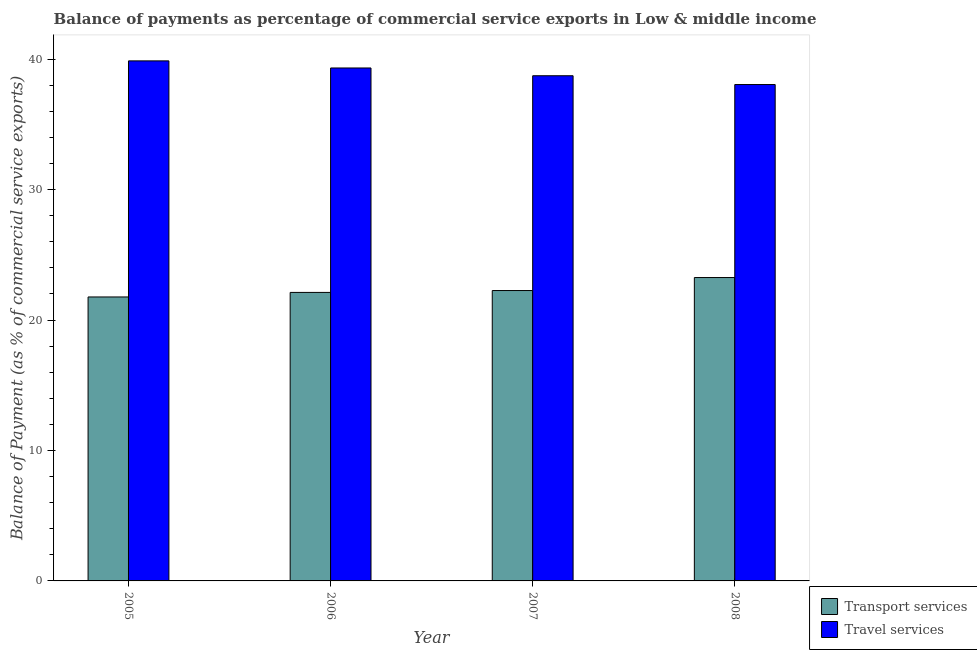How many different coloured bars are there?
Your answer should be compact. 2. How many groups of bars are there?
Give a very brief answer. 4. Are the number of bars per tick equal to the number of legend labels?
Provide a short and direct response. Yes. How many bars are there on the 1st tick from the right?
Ensure brevity in your answer.  2. What is the balance of payments of transport services in 2006?
Your response must be concise. 22.12. Across all years, what is the maximum balance of payments of transport services?
Keep it short and to the point. 23.26. Across all years, what is the minimum balance of payments of travel services?
Make the answer very short. 38.06. In which year was the balance of payments of travel services minimum?
Offer a terse response. 2008. What is the total balance of payments of travel services in the graph?
Your response must be concise. 155.98. What is the difference between the balance of payments of travel services in 2006 and that in 2008?
Ensure brevity in your answer.  1.27. What is the difference between the balance of payments of transport services in 2008 and the balance of payments of travel services in 2007?
Your response must be concise. 1. What is the average balance of payments of transport services per year?
Give a very brief answer. 22.35. What is the ratio of the balance of payments of transport services in 2006 to that in 2007?
Make the answer very short. 0.99. Is the balance of payments of travel services in 2006 less than that in 2007?
Ensure brevity in your answer.  No. Is the difference between the balance of payments of transport services in 2005 and 2007 greater than the difference between the balance of payments of travel services in 2005 and 2007?
Provide a succinct answer. No. What is the difference between the highest and the second highest balance of payments of transport services?
Make the answer very short. 1. What is the difference between the highest and the lowest balance of payments of travel services?
Provide a succinct answer. 1.81. In how many years, is the balance of payments of transport services greater than the average balance of payments of transport services taken over all years?
Provide a succinct answer. 1. Is the sum of the balance of payments of travel services in 2007 and 2008 greater than the maximum balance of payments of transport services across all years?
Keep it short and to the point. Yes. What does the 1st bar from the left in 2006 represents?
Provide a short and direct response. Transport services. What does the 2nd bar from the right in 2006 represents?
Ensure brevity in your answer.  Transport services. How many bars are there?
Ensure brevity in your answer.  8. Are all the bars in the graph horizontal?
Keep it short and to the point. No. How many years are there in the graph?
Make the answer very short. 4. Are the values on the major ticks of Y-axis written in scientific E-notation?
Offer a very short reply. No. Does the graph contain any zero values?
Your response must be concise. No. How are the legend labels stacked?
Your answer should be very brief. Vertical. What is the title of the graph?
Offer a terse response. Balance of payments as percentage of commercial service exports in Low & middle income. Does "Current education expenditure" appear as one of the legend labels in the graph?
Keep it short and to the point. No. What is the label or title of the X-axis?
Your answer should be very brief. Year. What is the label or title of the Y-axis?
Provide a succinct answer. Balance of Payment (as % of commercial service exports). What is the Balance of Payment (as % of commercial service exports) of Transport services in 2005?
Your response must be concise. 21.77. What is the Balance of Payment (as % of commercial service exports) of Travel services in 2005?
Offer a very short reply. 39.87. What is the Balance of Payment (as % of commercial service exports) in Transport services in 2006?
Provide a short and direct response. 22.12. What is the Balance of Payment (as % of commercial service exports) in Travel services in 2006?
Your answer should be compact. 39.33. What is the Balance of Payment (as % of commercial service exports) of Transport services in 2007?
Provide a succinct answer. 22.26. What is the Balance of Payment (as % of commercial service exports) in Travel services in 2007?
Provide a succinct answer. 38.73. What is the Balance of Payment (as % of commercial service exports) of Transport services in 2008?
Offer a very short reply. 23.26. What is the Balance of Payment (as % of commercial service exports) of Travel services in 2008?
Give a very brief answer. 38.06. Across all years, what is the maximum Balance of Payment (as % of commercial service exports) in Transport services?
Provide a short and direct response. 23.26. Across all years, what is the maximum Balance of Payment (as % of commercial service exports) in Travel services?
Provide a succinct answer. 39.87. Across all years, what is the minimum Balance of Payment (as % of commercial service exports) of Transport services?
Give a very brief answer. 21.77. Across all years, what is the minimum Balance of Payment (as % of commercial service exports) of Travel services?
Provide a succinct answer. 38.06. What is the total Balance of Payment (as % of commercial service exports) of Transport services in the graph?
Provide a succinct answer. 89.41. What is the total Balance of Payment (as % of commercial service exports) in Travel services in the graph?
Ensure brevity in your answer.  155.98. What is the difference between the Balance of Payment (as % of commercial service exports) in Transport services in 2005 and that in 2006?
Offer a terse response. -0.35. What is the difference between the Balance of Payment (as % of commercial service exports) in Travel services in 2005 and that in 2006?
Offer a very short reply. 0.54. What is the difference between the Balance of Payment (as % of commercial service exports) of Transport services in 2005 and that in 2007?
Provide a short and direct response. -0.49. What is the difference between the Balance of Payment (as % of commercial service exports) of Travel services in 2005 and that in 2007?
Give a very brief answer. 1.14. What is the difference between the Balance of Payment (as % of commercial service exports) in Transport services in 2005 and that in 2008?
Make the answer very short. -1.49. What is the difference between the Balance of Payment (as % of commercial service exports) of Travel services in 2005 and that in 2008?
Keep it short and to the point. 1.81. What is the difference between the Balance of Payment (as % of commercial service exports) of Transport services in 2006 and that in 2007?
Your response must be concise. -0.14. What is the difference between the Balance of Payment (as % of commercial service exports) in Travel services in 2006 and that in 2007?
Give a very brief answer. 0.6. What is the difference between the Balance of Payment (as % of commercial service exports) of Transport services in 2006 and that in 2008?
Offer a terse response. -1.14. What is the difference between the Balance of Payment (as % of commercial service exports) in Travel services in 2006 and that in 2008?
Provide a short and direct response. 1.27. What is the difference between the Balance of Payment (as % of commercial service exports) in Transport services in 2007 and that in 2008?
Your answer should be compact. -1. What is the difference between the Balance of Payment (as % of commercial service exports) of Travel services in 2007 and that in 2008?
Provide a short and direct response. 0.67. What is the difference between the Balance of Payment (as % of commercial service exports) of Transport services in 2005 and the Balance of Payment (as % of commercial service exports) of Travel services in 2006?
Provide a short and direct response. -17.56. What is the difference between the Balance of Payment (as % of commercial service exports) in Transport services in 2005 and the Balance of Payment (as % of commercial service exports) in Travel services in 2007?
Your answer should be compact. -16.96. What is the difference between the Balance of Payment (as % of commercial service exports) of Transport services in 2005 and the Balance of Payment (as % of commercial service exports) of Travel services in 2008?
Ensure brevity in your answer.  -16.28. What is the difference between the Balance of Payment (as % of commercial service exports) of Transport services in 2006 and the Balance of Payment (as % of commercial service exports) of Travel services in 2007?
Offer a very short reply. -16.61. What is the difference between the Balance of Payment (as % of commercial service exports) in Transport services in 2006 and the Balance of Payment (as % of commercial service exports) in Travel services in 2008?
Offer a very short reply. -15.94. What is the difference between the Balance of Payment (as % of commercial service exports) of Transport services in 2007 and the Balance of Payment (as % of commercial service exports) of Travel services in 2008?
Ensure brevity in your answer.  -15.79. What is the average Balance of Payment (as % of commercial service exports) in Transport services per year?
Keep it short and to the point. 22.35. What is the average Balance of Payment (as % of commercial service exports) of Travel services per year?
Your answer should be compact. 38.99. In the year 2005, what is the difference between the Balance of Payment (as % of commercial service exports) in Transport services and Balance of Payment (as % of commercial service exports) in Travel services?
Your answer should be very brief. -18.1. In the year 2006, what is the difference between the Balance of Payment (as % of commercial service exports) of Transport services and Balance of Payment (as % of commercial service exports) of Travel services?
Provide a short and direct response. -17.21. In the year 2007, what is the difference between the Balance of Payment (as % of commercial service exports) of Transport services and Balance of Payment (as % of commercial service exports) of Travel services?
Your answer should be compact. -16.47. In the year 2008, what is the difference between the Balance of Payment (as % of commercial service exports) of Transport services and Balance of Payment (as % of commercial service exports) of Travel services?
Give a very brief answer. -14.8. What is the ratio of the Balance of Payment (as % of commercial service exports) in Transport services in 2005 to that in 2006?
Make the answer very short. 0.98. What is the ratio of the Balance of Payment (as % of commercial service exports) of Travel services in 2005 to that in 2006?
Offer a very short reply. 1.01. What is the ratio of the Balance of Payment (as % of commercial service exports) in Transport services in 2005 to that in 2007?
Give a very brief answer. 0.98. What is the ratio of the Balance of Payment (as % of commercial service exports) of Travel services in 2005 to that in 2007?
Offer a very short reply. 1.03. What is the ratio of the Balance of Payment (as % of commercial service exports) of Transport services in 2005 to that in 2008?
Your response must be concise. 0.94. What is the ratio of the Balance of Payment (as % of commercial service exports) in Travel services in 2005 to that in 2008?
Your answer should be very brief. 1.05. What is the ratio of the Balance of Payment (as % of commercial service exports) of Travel services in 2006 to that in 2007?
Your answer should be compact. 1.02. What is the ratio of the Balance of Payment (as % of commercial service exports) in Transport services in 2006 to that in 2008?
Offer a very short reply. 0.95. What is the ratio of the Balance of Payment (as % of commercial service exports) of Travel services in 2006 to that in 2008?
Keep it short and to the point. 1.03. What is the ratio of the Balance of Payment (as % of commercial service exports) of Transport services in 2007 to that in 2008?
Give a very brief answer. 0.96. What is the ratio of the Balance of Payment (as % of commercial service exports) of Travel services in 2007 to that in 2008?
Give a very brief answer. 1.02. What is the difference between the highest and the second highest Balance of Payment (as % of commercial service exports) in Travel services?
Offer a terse response. 0.54. What is the difference between the highest and the lowest Balance of Payment (as % of commercial service exports) of Transport services?
Your answer should be compact. 1.49. What is the difference between the highest and the lowest Balance of Payment (as % of commercial service exports) in Travel services?
Give a very brief answer. 1.81. 